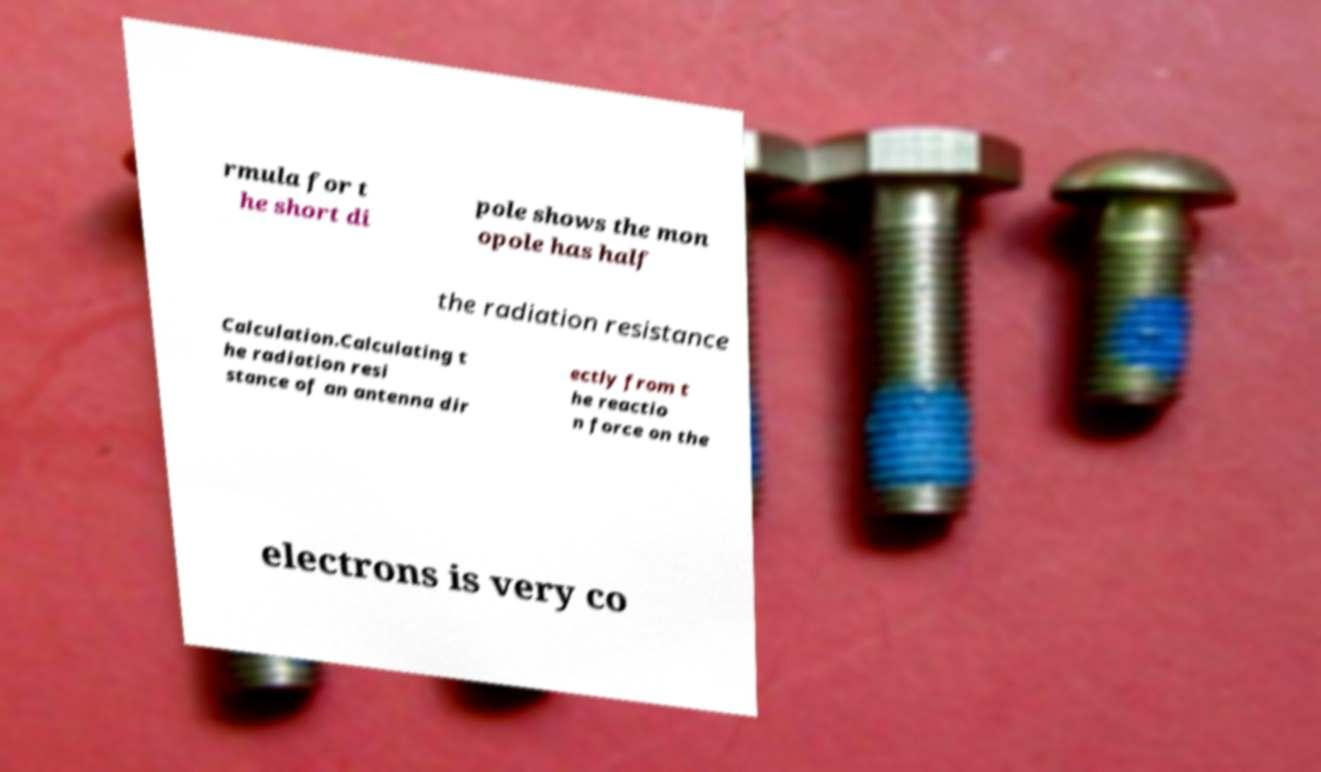Please read and relay the text visible in this image. What does it say? rmula for t he short di pole shows the mon opole has half the radiation resistance Calculation.Calculating t he radiation resi stance of an antenna dir ectly from t he reactio n force on the electrons is very co 